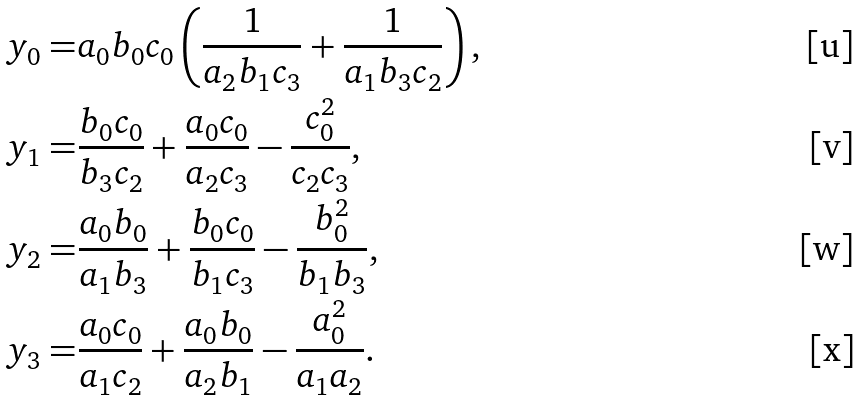Convert formula to latex. <formula><loc_0><loc_0><loc_500><loc_500>y _ { 0 } = & a _ { 0 } b _ { 0 } c _ { 0 } \left ( \frac { 1 } { a _ { 2 } b _ { 1 } c _ { 3 } } + \frac { 1 } { a _ { 1 } b _ { 3 } c _ { 2 } } \right ) , \\ y _ { 1 } = & \frac { b _ { 0 } c _ { 0 } } { b _ { 3 } c _ { 2 } } + \frac { a _ { 0 } c _ { 0 } } { a _ { 2 } c _ { 3 } } - \frac { c _ { 0 } ^ { 2 } } { c _ { 2 } c _ { 3 } } , \\ y _ { 2 } = & \frac { a _ { 0 } b _ { 0 } } { a _ { 1 } b _ { 3 } } + \frac { b _ { 0 } c _ { 0 } } { b _ { 1 } c _ { 3 } } - \frac { b _ { 0 } ^ { 2 } } { b _ { 1 } b _ { 3 } } , \\ y _ { 3 } = & \frac { a _ { 0 } c _ { 0 } } { a _ { 1 } c _ { 2 } } + \frac { a _ { 0 } b _ { 0 } } { a _ { 2 } b _ { 1 } } - \frac { a _ { 0 } ^ { 2 } } { a _ { 1 } a _ { 2 } } .</formula> 